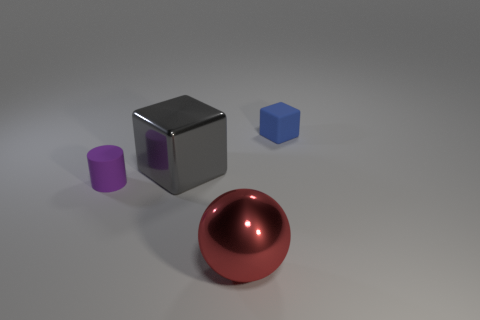Add 4 tiny blue objects. How many objects exist? 8 Subtract all blue blocks. How many blocks are left? 1 Subtract all spheres. How many objects are left? 3 Add 2 big purple rubber cylinders. How many big purple rubber cylinders exist? 2 Subtract 1 purple cylinders. How many objects are left? 3 Subtract 1 spheres. How many spheres are left? 0 Subtract all green cubes. Subtract all yellow cylinders. How many cubes are left? 2 Subtract all tiny purple objects. Subtract all tiny blue cylinders. How many objects are left? 3 Add 4 blocks. How many blocks are left? 6 